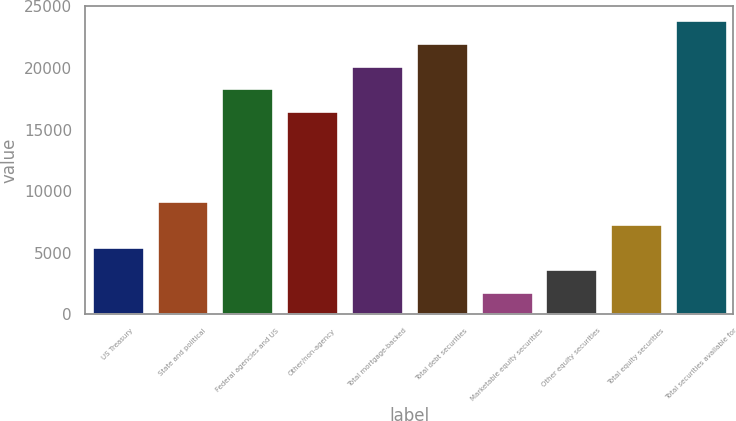<chart> <loc_0><loc_0><loc_500><loc_500><bar_chart><fcel>US Treasury<fcel>State and political<fcel>Federal agencies and US<fcel>Other/non-agency<fcel>Total mortgage-backed<fcel>Total debt securities<fcel>Marketable equity securities<fcel>Other equity securities<fcel>Total equity securities<fcel>Total securities available for<nl><fcel>5511<fcel>9181<fcel>18356<fcel>16521<fcel>20191<fcel>22026<fcel>1841<fcel>3676<fcel>7346<fcel>23861<nl></chart> 